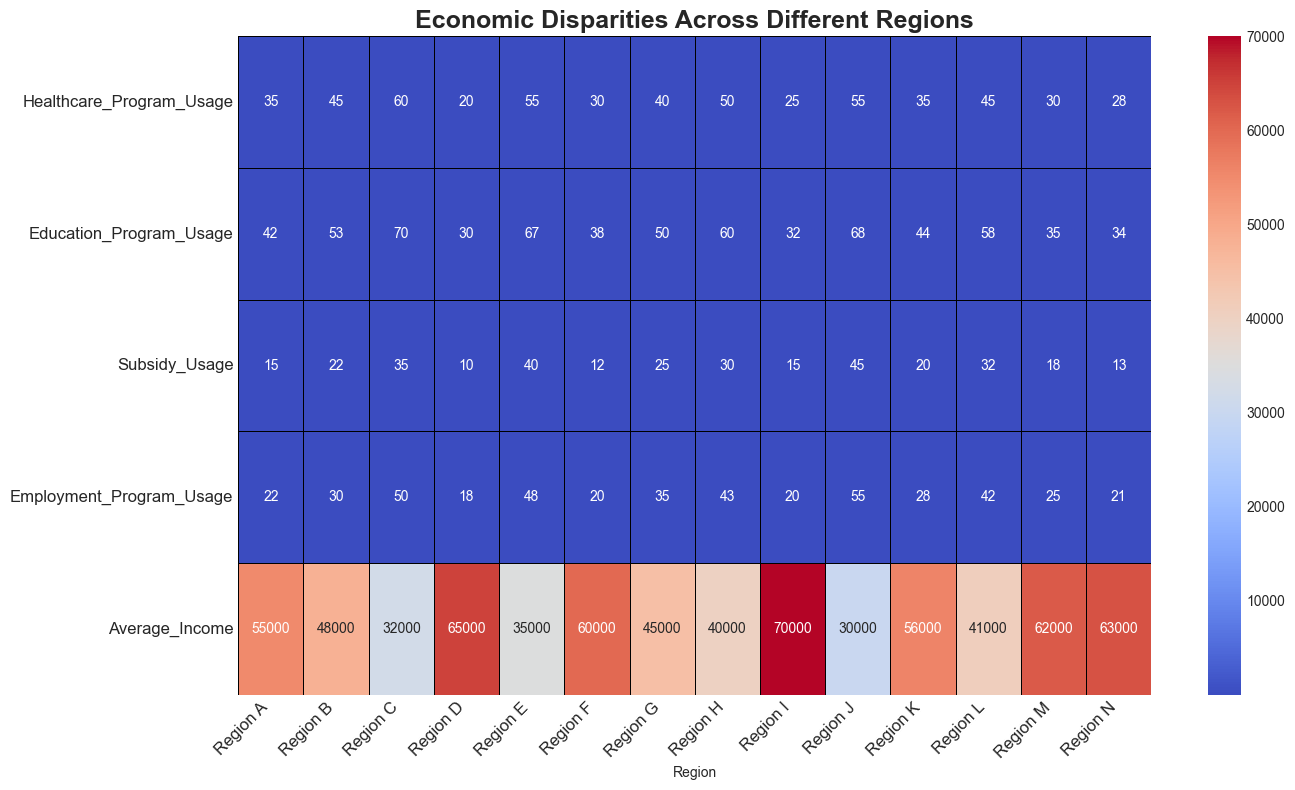What region has the highest usage of healthcare programs? To determine which region has the highest usage of healthcare programs, look for the highest value in the "Healthcare_Program_Usage" row of the heatmap.
Answer: Region C What is the difference in both healthcare and education program usage between Regions J and I? To find this difference, subtract the healthcare and education program usage of Region I from Region J for both categories: (Healthcare: 55 - 25, Education: 68 - 32). The differences are 30 for healthcare and 36 for education.
Answer: 30 for healthcare, 36 for education Which region shows the lowest usage of employment programs? To identify the region with the lowest usage of employment programs, look for the smallest value in the "Employment_Program_Usage" row of the heatmap.
Answer: Region D Compare the average income between Region C and Region M. Which one is higher and by how much? To compare the average incomes, subtract the average income of Region C from Region M: (62000 - 32000). The average income of Region M is higher by 30000.
Answer: Region M, higher by 30000 What is the average usage of educational programs across all regions? To find the average usage of educational programs, sum the values in the "Education_Program_Usage" row and divide by the number of regions (14): (42+53+70+30+67+38+50+60+32+68+44+58+35+34)/14 = 49.143.
Answer: 49.143 Which region has the highest combined usage of subsidy and employment programs, and what is that total? To find this, sum the values of "Subsidy_Usage" and "Employment_Program_Usage" for each region and identify the maximum. The highest combined total is for Region J: 45 + 55 = 100.
Answer: Region J, 100 How does the employment program usage in Region N compare to Region G? In the heatmap, find the values for "Employment_Program_Usage" for both regions and compare: Region N=21, Region G=35. Region G has higher usage than Region N by 14.
Answer: Region G, higher by 14 Which regions have an average income greater than 60000, and what are their corresponding healthcare usage values? Look for regions with an average income greater than 60000 and note their healthcare program usage: Regions I, D, M, and N with corresponding healthcare usage values of 25, 20, 30, and 28 respectively.
Answer: Regions I (25), D (20), M (30), N (28) What is the range of values in the subsidy usage category? To determine the range, subtract the smallest value in the "Subsidy_Usage" row from the largest value: (45 - 10). The range of subsidy usage is 35.
Answer: 35 